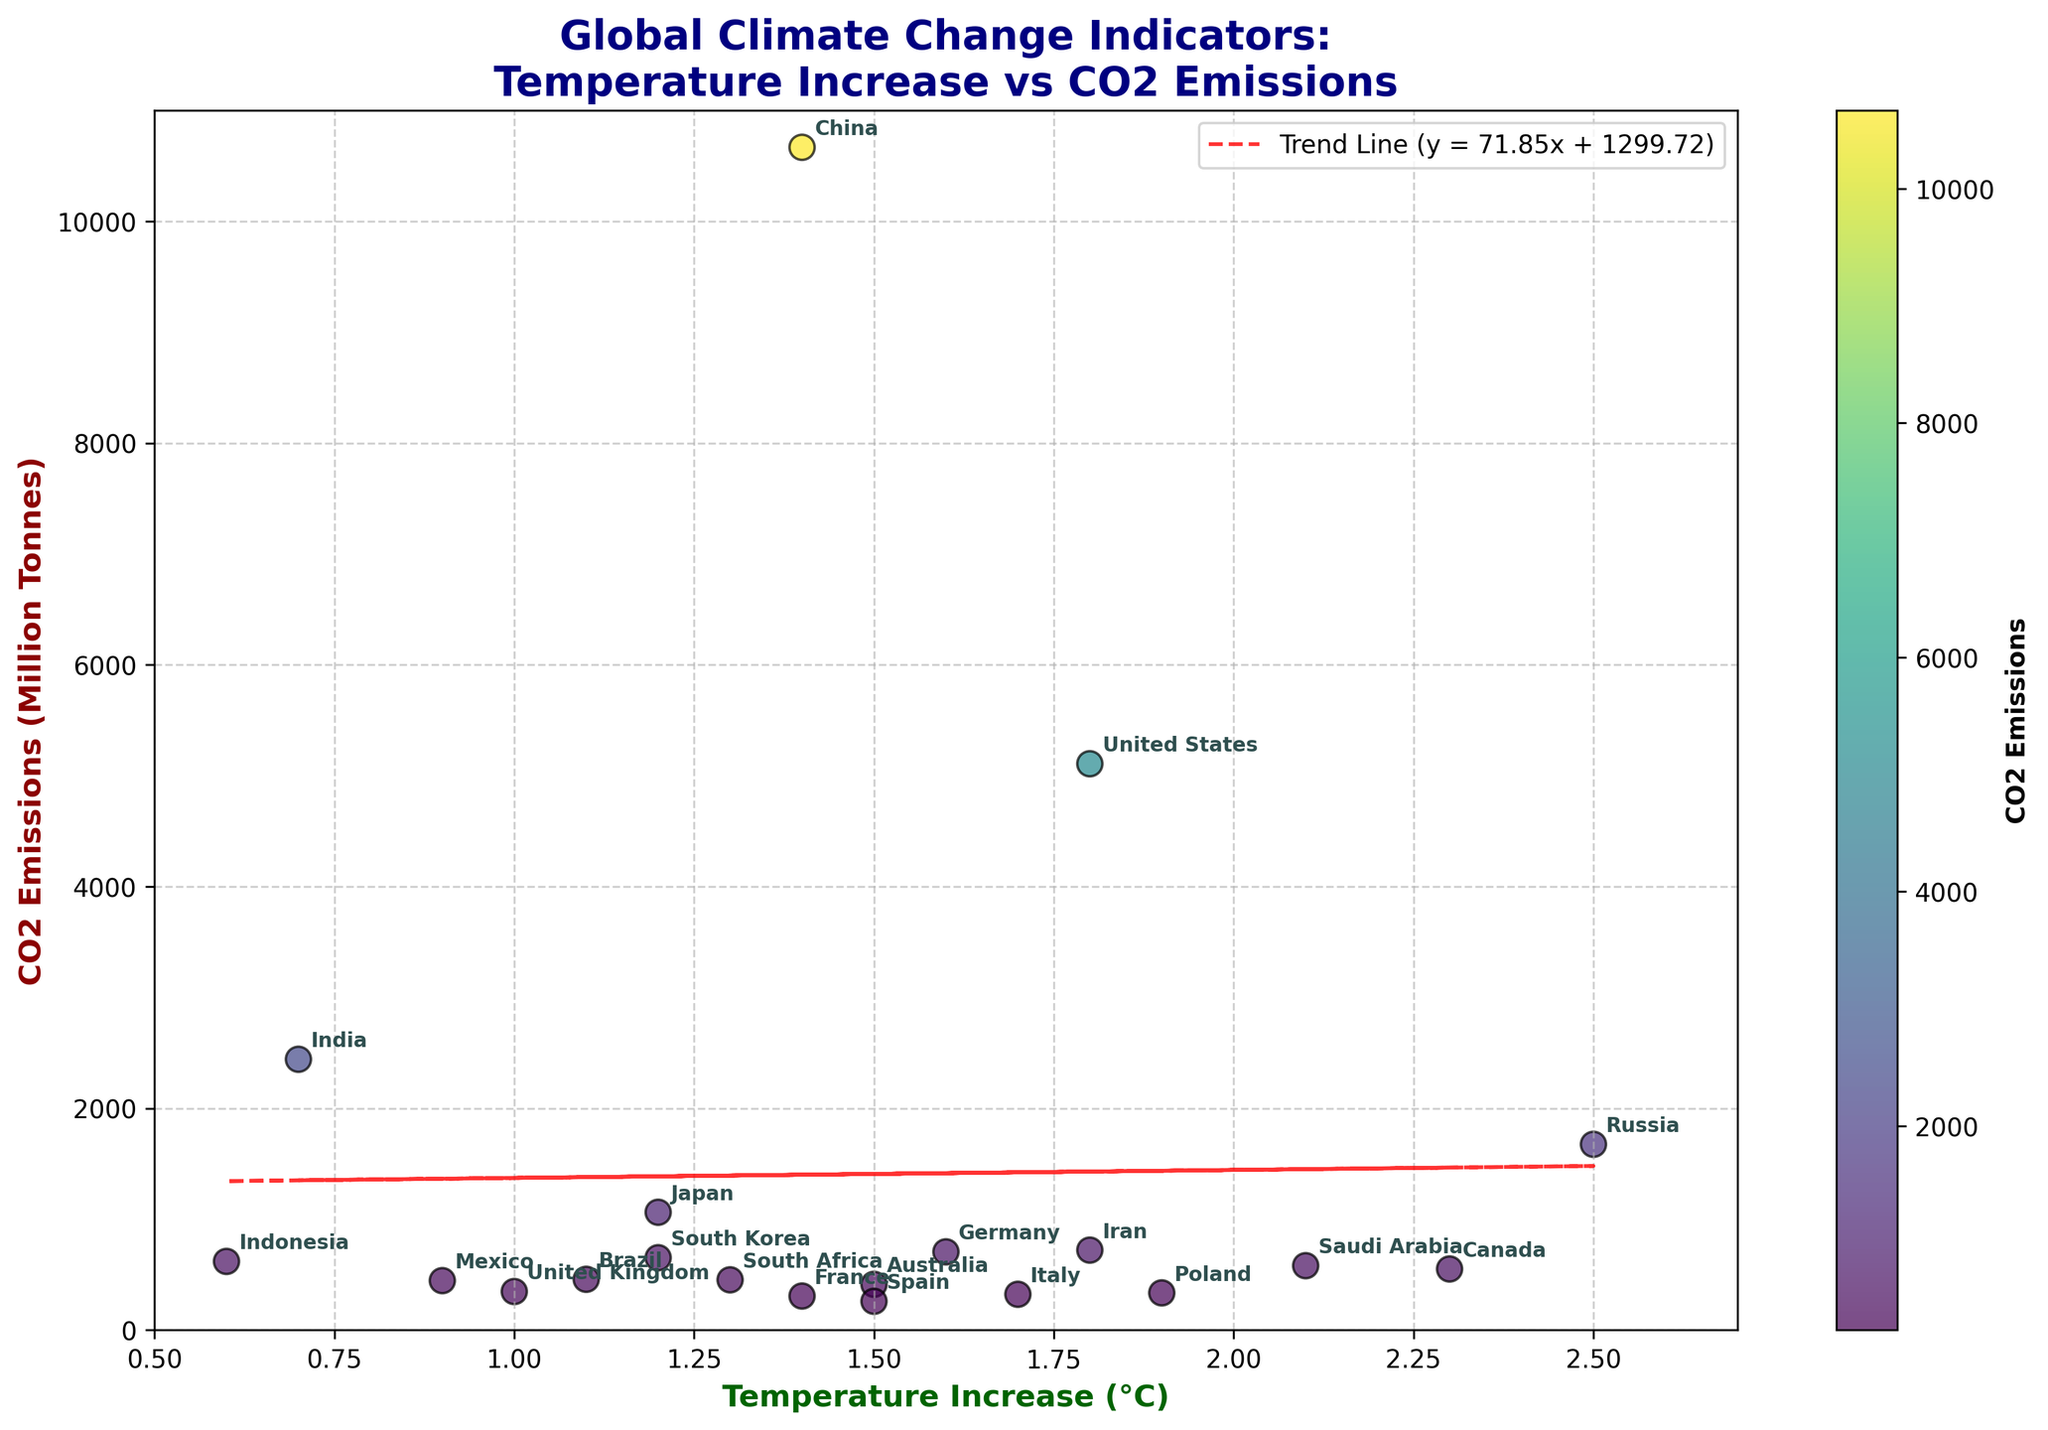What is the title of the figure? The title is located at the top of the figure and provides a summary of what the figure is about.
Answer: Global Climate Change Indicators: Temperature Increase vs CO2 Emissions Which country has the highest CO2 emissions? By observing the y-axis values and matching the points, China has the highest CO2 emissions.
Answer: China What is the temperature increase for Canada? Find the point labeled Canada on the plot and check its corresponding x-axis value.
Answer: 2.3°C How many countries have a temperature increase higher than 2°C? Count the number of points where the temperature increase on the x-axis is greater than 2.0°C.
Answer: 3 Which countries have a temperature increase between 1.5°C and 1.8°C? Identify the points within the 1.5°C to 1.8°C range on the x-axis and check the respective country labels.
Answer: Germany, Iran, and Italy What is the general trend between temperature increase and CO2 emissions? The trend line equation and direction help us interpret the relationship; the positive slope suggests a direct relationship.
Answer: Positive trend What is the approximate CO2 emission value for India? Find the point labeled India and check its corresponding y-axis value.
Answer: Approximately 2441.792 Million Tonnes Compare the CO2 emissions of the United States and Mexico. Locate both points on the y-axis, observe and subtract Mexico's value from the United States'.
Answer: United States is higher by 4662.267 Million Tonnes Which country has the smallest CO2 emissions? Find the country label with the lowest position on the y-axis.
Answer: Spain Is there a country with a temperature increase above 2°C but with CO2 emissions below 600 Million Tonnes? Scan the plot for points where x-axis > 2°C and y-axis < 600 Million Tonnes, and identify the country labels.
Answer: Russia and Canada 